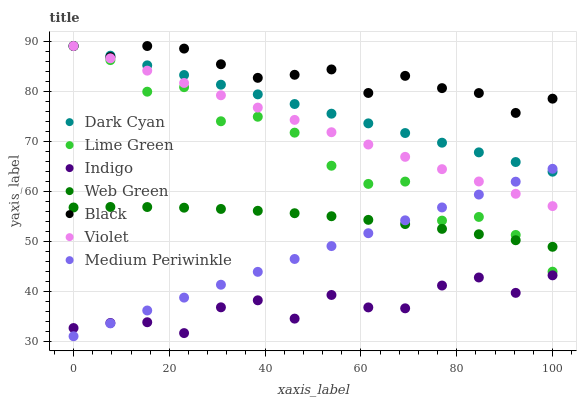Does Indigo have the minimum area under the curve?
Answer yes or no. Yes. Does Black have the maximum area under the curve?
Answer yes or no. Yes. Does Medium Periwinkle have the minimum area under the curve?
Answer yes or no. No. Does Medium Periwinkle have the maximum area under the curve?
Answer yes or no. No. Is Dark Cyan the smoothest?
Answer yes or no. Yes. Is Lime Green the roughest?
Answer yes or no. Yes. Is Medium Periwinkle the smoothest?
Answer yes or no. No. Is Medium Periwinkle the roughest?
Answer yes or no. No. Does Medium Periwinkle have the lowest value?
Answer yes or no. Yes. Does Web Green have the lowest value?
Answer yes or no. No. Does Lime Green have the highest value?
Answer yes or no. Yes. Does Medium Periwinkle have the highest value?
Answer yes or no. No. Is Indigo less than Violet?
Answer yes or no. Yes. Is Violet greater than Indigo?
Answer yes or no. Yes. Does Violet intersect Medium Periwinkle?
Answer yes or no. Yes. Is Violet less than Medium Periwinkle?
Answer yes or no. No. Is Violet greater than Medium Periwinkle?
Answer yes or no. No. Does Indigo intersect Violet?
Answer yes or no. No. 